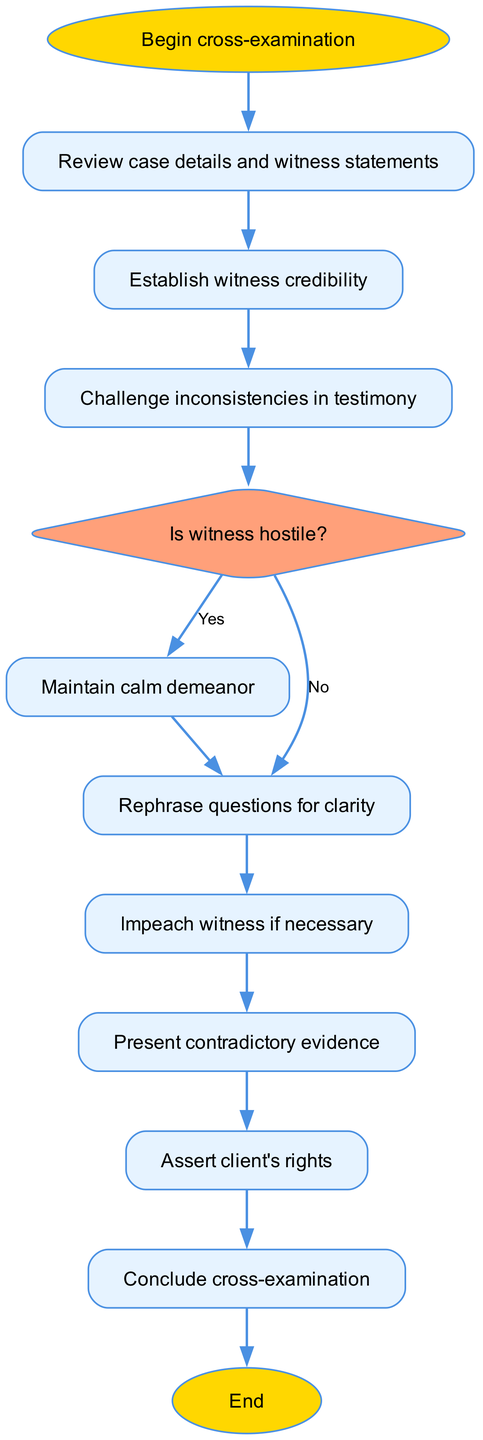What is the first step in the cross-examination process? The diagram starts with the "Begin cross-examination" node, indicating that this is the first action to take in the process.
Answer: Begin cross-examination How many main steps are involved before concluding the cross-examination? Counting the connections from "Prepare" to "Conclude," there are 9 nodes involved before reaching the conclusion point, starting with "Prepare" and ending at "Conclude."
Answer: 9 What type of node is the "hostile" decision point? In the diagram, the "hostile" node is represented as a diamond shape, which is characteristic of decision points in a flowchart.
Answer: Diamond What should you do if the witness is hostile? According to the diagram, if the witness is hostile, you should "Maintain calm demeanor" to handle the situation effectively.
Answer: Maintain calm demeanor What is the last action taken in the cross-examination process? The flowchart specifies that the last action is "End," signifying the conclusion of the entire cross-examination process.
Answer: End What steps are involved after rephrasing questions? After "Rephrase questions for clarity," the next steps in sequence are "Impeach witness if necessary" and subsequently "Present contradictory evidence."
Answer: Impeach witness if necessary, Present contradictory evidence Where does the step "Assert client's rights" fit in the process? Based on the diagram, "Assert client's rights" follows the step of presenting contradictory evidence and comes before concluding the cross-examination.
Answer: After presenting contradictory evidence If the witness is not hostile, which step should follow? If the witness is not deemed hostile, you should proceed to "Rephrase questions for clarity" as indicated in the flowchart.
Answer: Rephrase questions for clarity How do you handle inconsistencies in witness testimony? The diagram indicates that the next step after "Establish witness credibility" is to "Challenge inconsistencies in testimony," suggesting this is how you handle such situations.
Answer: Challenge inconsistencies in testimony 